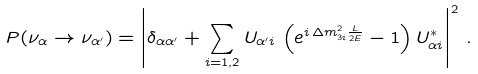<formula> <loc_0><loc_0><loc_500><loc_500>P ( \nu _ { \alpha } \to \nu _ { \alpha ^ { \prime } } ) = \left | \delta _ { \alpha \alpha ^ { \prime } } + \sum _ { i = 1 , 2 } U _ { { \alpha ^ { \prime } } i } \, \left ( e ^ { i \, \Delta m ^ { 2 } _ { 3 i } \frac { L } { 2 E } } - 1 \right ) U _ { { \alpha } i } ^ { * } \right | ^ { 2 } \, .</formula> 